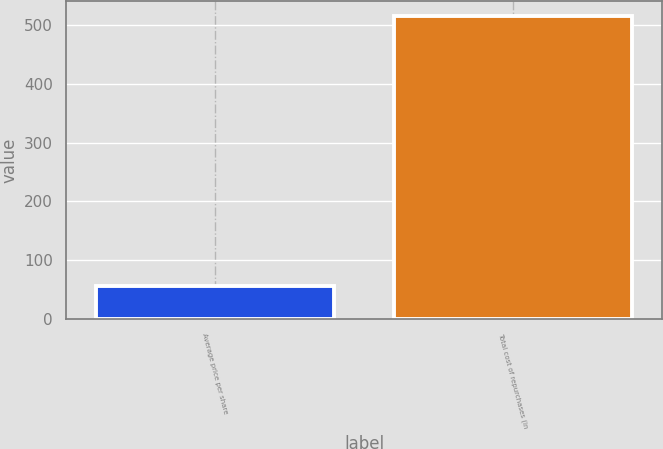Convert chart. <chart><loc_0><loc_0><loc_500><loc_500><bar_chart><fcel>Average price per share<fcel>Total cost of repurchases (in<nl><fcel>55.59<fcel>515<nl></chart> 